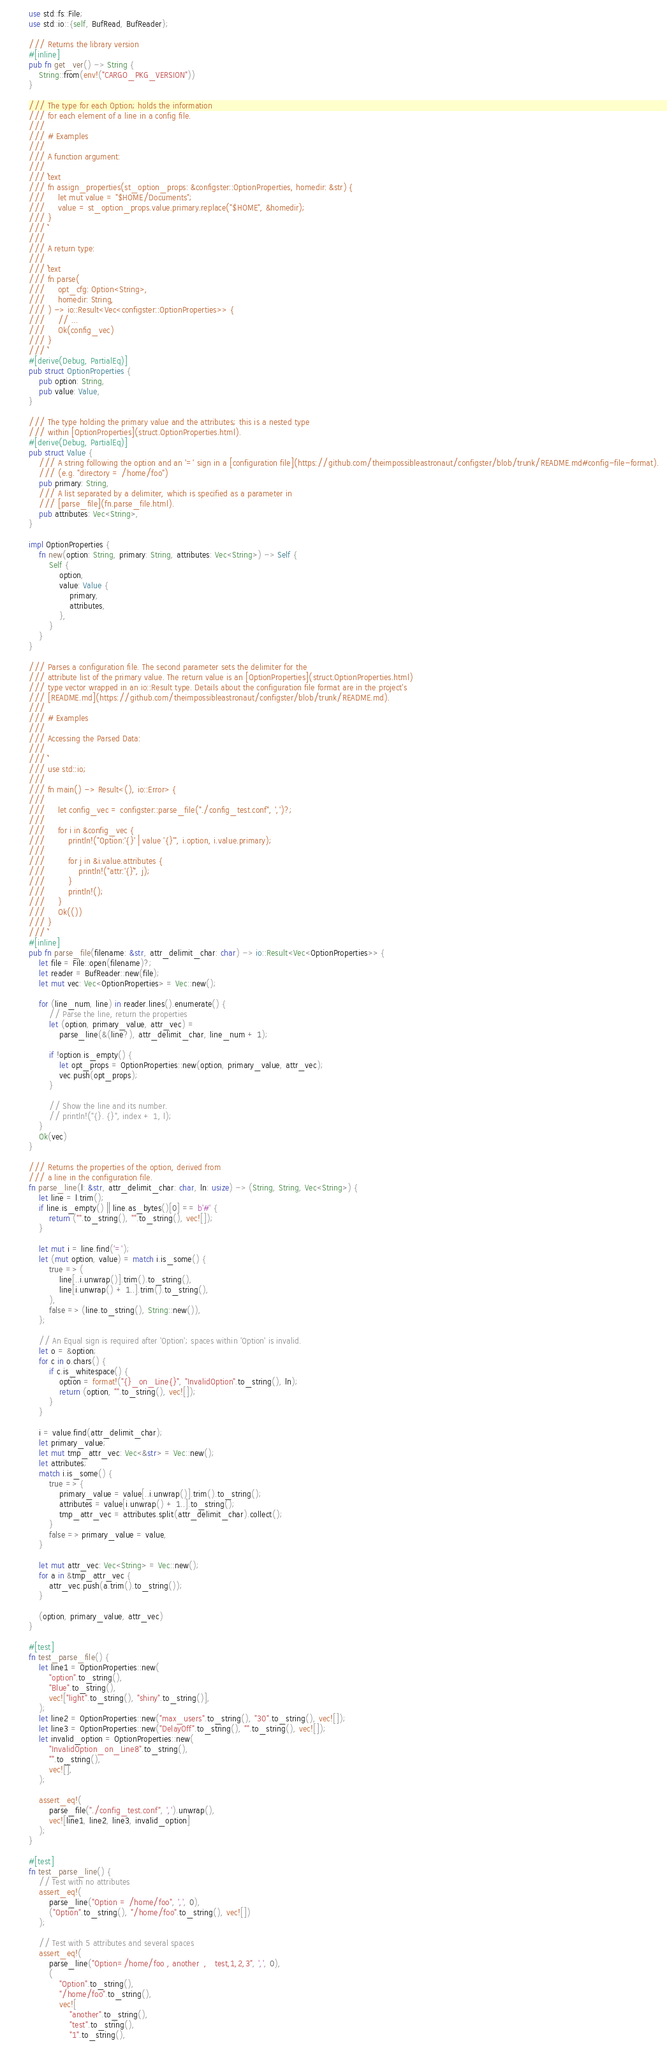Convert code to text. <code><loc_0><loc_0><loc_500><loc_500><_Rust_>use std::fs::File;
use std::io::{self, BufRead, BufReader};

/// Returns the library version
#[inline]
pub fn get_ver() -> String {
    String::from(env!("CARGO_PKG_VERSION"))
}

/// The type for each Option; holds the information
/// for each element of a line in a config file.
///
/// # Examples
///
/// A function argument:
///
/// ```text
/// fn assign_properties(st_option_props: &configster::OptionProperties, homedir: &str) {
///     let mut value = "$HOME/Documents";
///     value = st_option_props.value.primary.replace("$HOME", &homedir);
/// }
/// ```
///
/// A return type:
///
/// ```text
/// fn parse(
///     opt_cfg: Option<String>,
///     homedir: String,
/// ) -> io::Result<Vec<configster::OptionProperties>> {
///     // ...
///     Ok(config_vec)
/// }
/// ```
#[derive(Debug, PartialEq)]
pub struct OptionProperties {
    pub option: String,
    pub value: Value,
}

/// The type holding the primary value and the attributes; this is a nested type
/// within [OptionProperties](struct.OptionProperties.html).
#[derive(Debug, PartialEq)]
pub struct Value {
    /// A string following the option and an '=' sign in a [configuration file](https://github.com/theimpossibleastronaut/configster/blob/trunk/README.md#config-file-format).
    /// (e.g. "directory = /home/foo")
    pub primary: String,
    /// A list separated by a delimiter, which is specified as a parameter in
    /// [parse_file](fn.parse_file.html).
    pub attributes: Vec<String>,
}

impl OptionProperties {
    fn new(option: String, primary: String, attributes: Vec<String>) -> Self {
        Self {
            option,
            value: Value {
                primary,
                attributes,
            },
        }
    }
}

/// Parses a configuration file. The second parameter sets the delimiter for the
/// attribute list of the primary value. The return value is an [OptionProperties](struct.OptionProperties.html)
/// type vector wrapped in an io::Result type. Details about the configuration file format are in the project's
/// [README.md](https://github.com/theimpossibleastronaut/configster/blob/trunk/README.md).
///
/// # Examples
///
/// Accessing the Parsed Data:
///
/// ```
/// use std::io;
///
/// fn main() -> Result<(), io::Error> {
///
///     let config_vec = configster::parse_file("./config_test.conf", ',')?;
///
///     for i in &config_vec {
///         println!("Option:'{}' | value '{}'", i.option, i.value.primary);
///
///         for j in &i.value.attributes {
///             println!("attr:'{}`", j);
///         }
///         println!();
///     }
///     Ok(())
/// }
/// ```
#[inline]
pub fn parse_file(filename: &str, attr_delimit_char: char) -> io::Result<Vec<OptionProperties>> {
    let file = File::open(filename)?;
    let reader = BufReader::new(file);
    let mut vec: Vec<OptionProperties> = Vec::new();

    for (line_num, line) in reader.lines().enumerate() {
        // Parse the line, return the properties
        let (option, primary_value, attr_vec) =
            parse_line(&(line?), attr_delimit_char, line_num + 1);

        if !option.is_empty() {
            let opt_props = OptionProperties::new(option, primary_value, attr_vec);
            vec.push(opt_props);
        }

        // Show the line and its number.
        // println!("{}. {}", index + 1, l);
    }
    Ok(vec)
}

/// Returns the properties of the option, derived from
/// a line in the configuration file.
fn parse_line(l: &str, attr_delimit_char: char, ln: usize) -> (String, String, Vec<String>) {
    let line = l.trim();
    if line.is_empty() || line.as_bytes()[0] == b'#' {
        return ("".to_string(), "".to_string(), vec![]);
    }

    let mut i = line.find('=');
    let (mut option, value) = match i.is_some() {
        true => (
            line[..i.unwrap()].trim().to_string(),
            line[i.unwrap() + 1..].trim().to_string(),
        ),
        false => (line.to_string(), String::new()),
    };

    // An Equal sign is required after 'Option'; spaces within 'Option' is invalid.
    let o = &option;
    for c in o.chars() {
        if c.is_whitespace() {
            option = format!("{}_on_Line{}", "InvalidOption".to_string(), ln);
            return (option, "".to_string(), vec![]);
        }
    }

    i = value.find(attr_delimit_char);
    let primary_value;
    let mut tmp_attr_vec: Vec<&str> = Vec::new();
    let attributes;
    match i.is_some() {
        true => {
            primary_value = value[..i.unwrap()].trim().to_string();
            attributes = value[i.unwrap() + 1..].to_string();
            tmp_attr_vec = attributes.split(attr_delimit_char).collect();
        }
        false => primary_value = value,
    }

    let mut attr_vec: Vec<String> = Vec::new();
    for a in &tmp_attr_vec {
        attr_vec.push(a.trim().to_string());
    }

    (option, primary_value, attr_vec)
}

#[test]
fn test_parse_file() {
    let line1 = OptionProperties::new(
        "option".to_string(),
        "Blue".to_string(),
        vec!["light".to_string(), "shiny".to_string()],
    );
    let line2 = OptionProperties::new("max_users".to_string(), "30".to_string(), vec![]);
    let line3 = OptionProperties::new("DelayOff".to_string(), "".to_string(), vec![]);
    let invalid_option = OptionProperties::new(
        "InvalidOption_on_Line8".to_string(),
        "".to_string(),
        vec![],
    );

    assert_eq!(
        parse_file("./config_test.conf", ',').unwrap(),
        vec![line1, line2, line3, invalid_option]
    );
}

#[test]
fn test_parse_line() {
    // Test with no attributes
    assert_eq!(
        parse_line("Option = /home/foo", ',', 0),
        ("Option".to_string(), "/home/foo".to_string(), vec![])
    );

    // Test with 5 attributes and several spaces
    assert_eq!(
        parse_line("Option=/home/foo , another  ,   test,1,2,3", ',', 0),
        (
            "Option".to_string(),
            "/home/foo".to_string(),
            vec![
                "another".to_string(),
                "test".to_string(),
                "1".to_string(),</code> 